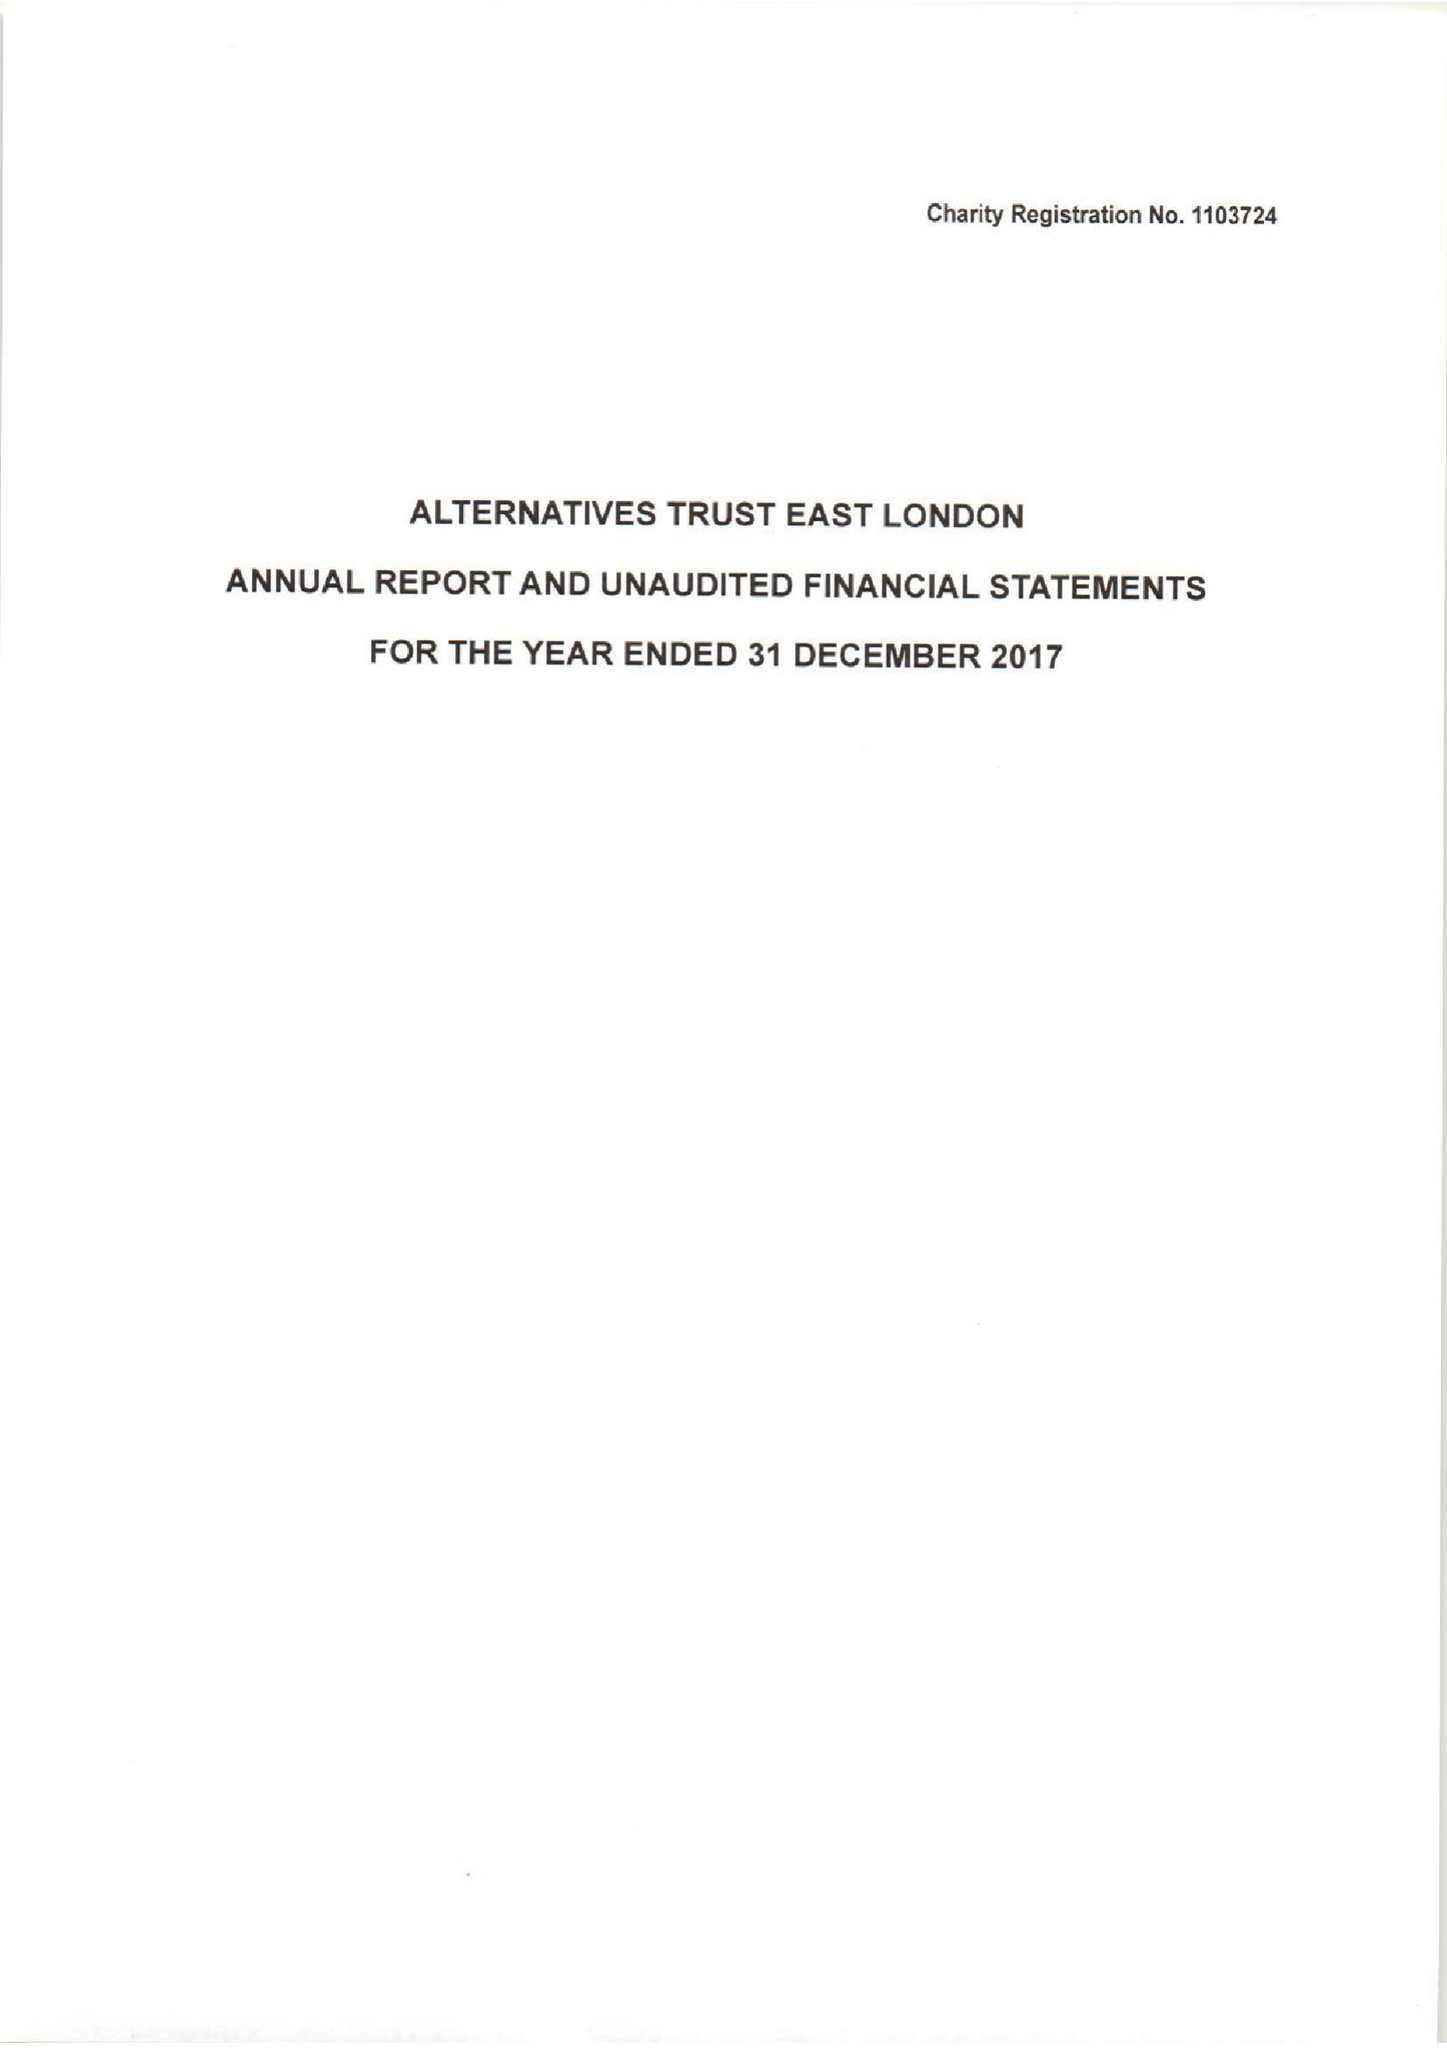What is the value for the address__postcode?
Answer the question using a single word or phrase. E13 8AB 